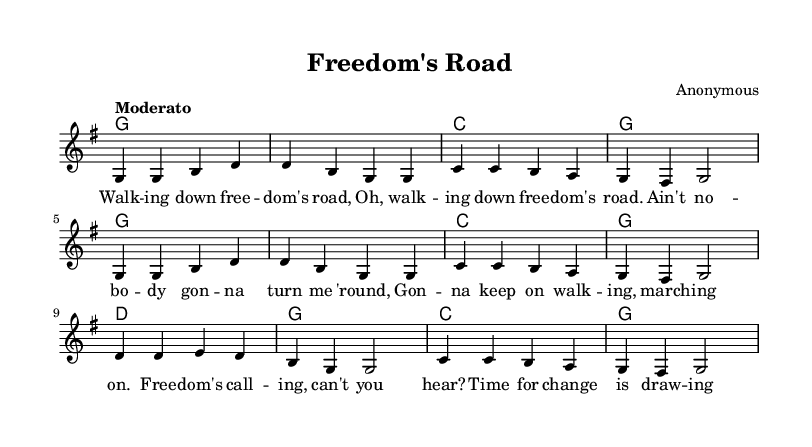what is the key signature of this music? The key signature indicated at the beginning of the sheet music shows one sharp, which corresponds to the key of G major.
Answer: G major what is the time signature of this music? The time signature is specified right at the beginning, showing 4 beats per measure, represented as 4/4.
Answer: 4/4 what is the tempo marking for this piece? The tempo is indicated as "Moderato" at the beginning of the sheet music, which suggests a moderate pace.
Answer: Moderato how many measures are in the melody? By counting the total number of measures listed in the melody section, we find that there are 8 individual measures.
Answer: 8 what are the primary chords used in this piece? The chord progression can be identified from the harmonies section; the primary chords are G, C, and D.
Answer: G, C, D analyze the song's structure: how many times is the phrase "walking down freedom's road" repeated? Observing the lyrics, the phrase "walking down freedom's road" appears twice in the first line, which leads us to state that this line is repeated.
Answer: 2 what is the overall theme conveyed in the lyrics of the song? The lyrics refer to a strong sense of perseverance and the quest for freedom, encouraging an unwavering spirit amid adversity.
Answer: Perseverance 